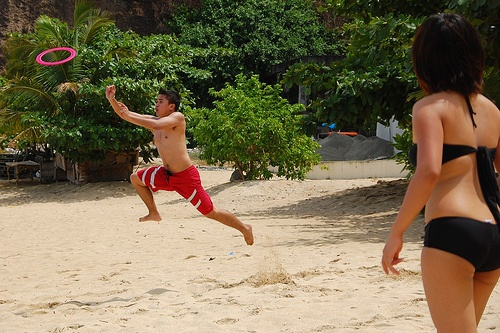Describe the objects in this image and their specific colors. I can see people in black, brown, salmon, and tan tones, people in black, brown, and maroon tones, and frisbee in black, violet, and darkgreen tones in this image. 